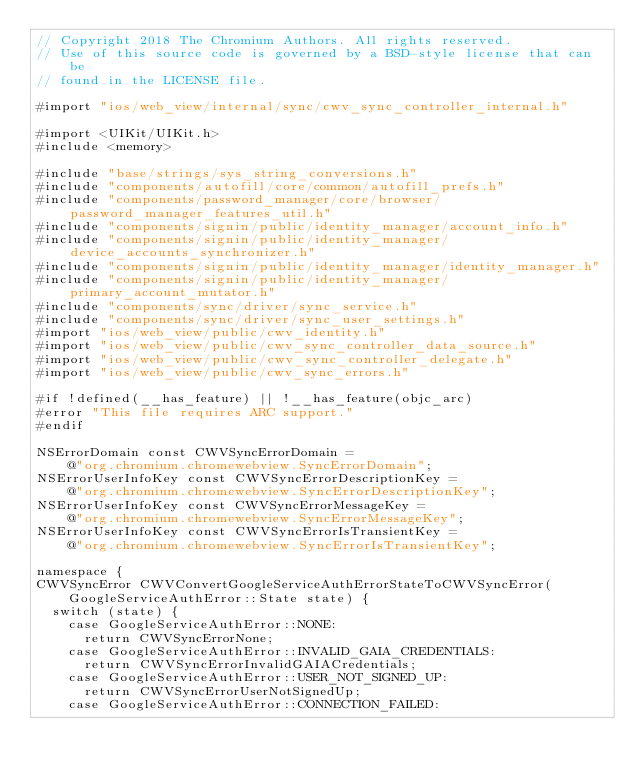Convert code to text. <code><loc_0><loc_0><loc_500><loc_500><_ObjectiveC_>// Copyright 2018 The Chromium Authors. All rights reserved.
// Use of this source code is governed by a BSD-style license that can be
// found in the LICENSE file.

#import "ios/web_view/internal/sync/cwv_sync_controller_internal.h"

#import <UIKit/UIKit.h>
#include <memory>

#include "base/strings/sys_string_conversions.h"
#include "components/autofill/core/common/autofill_prefs.h"
#include "components/password_manager/core/browser/password_manager_features_util.h"
#include "components/signin/public/identity_manager/account_info.h"
#include "components/signin/public/identity_manager/device_accounts_synchronizer.h"
#include "components/signin/public/identity_manager/identity_manager.h"
#include "components/signin/public/identity_manager/primary_account_mutator.h"
#include "components/sync/driver/sync_service.h"
#include "components/sync/driver/sync_user_settings.h"
#import "ios/web_view/public/cwv_identity.h"
#import "ios/web_view/public/cwv_sync_controller_data_source.h"
#import "ios/web_view/public/cwv_sync_controller_delegate.h"
#import "ios/web_view/public/cwv_sync_errors.h"

#if !defined(__has_feature) || !__has_feature(objc_arc)
#error "This file requires ARC support."
#endif

NSErrorDomain const CWVSyncErrorDomain =
    @"org.chromium.chromewebview.SyncErrorDomain";
NSErrorUserInfoKey const CWVSyncErrorDescriptionKey =
    @"org.chromium.chromewebview.SyncErrorDescriptionKey";
NSErrorUserInfoKey const CWVSyncErrorMessageKey =
    @"org.chromium.chromewebview.SyncErrorMessageKey";
NSErrorUserInfoKey const CWVSyncErrorIsTransientKey =
    @"org.chromium.chromewebview.SyncErrorIsTransientKey";

namespace {
CWVSyncError CWVConvertGoogleServiceAuthErrorStateToCWVSyncError(
    GoogleServiceAuthError::State state) {
  switch (state) {
    case GoogleServiceAuthError::NONE:
      return CWVSyncErrorNone;
    case GoogleServiceAuthError::INVALID_GAIA_CREDENTIALS:
      return CWVSyncErrorInvalidGAIACredentials;
    case GoogleServiceAuthError::USER_NOT_SIGNED_UP:
      return CWVSyncErrorUserNotSignedUp;
    case GoogleServiceAuthError::CONNECTION_FAILED:</code> 